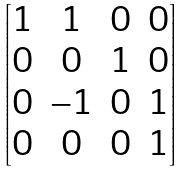Convert formula to latex. <formula><loc_0><loc_0><loc_500><loc_500>\begin{bmatrix} 1 & 1 & 0 & 0 \\ 0 & 0 & 1 & 0 \\ 0 & - 1 & 0 & 1 \\ 0 & 0 & 0 & 1 \end{bmatrix}</formula> 